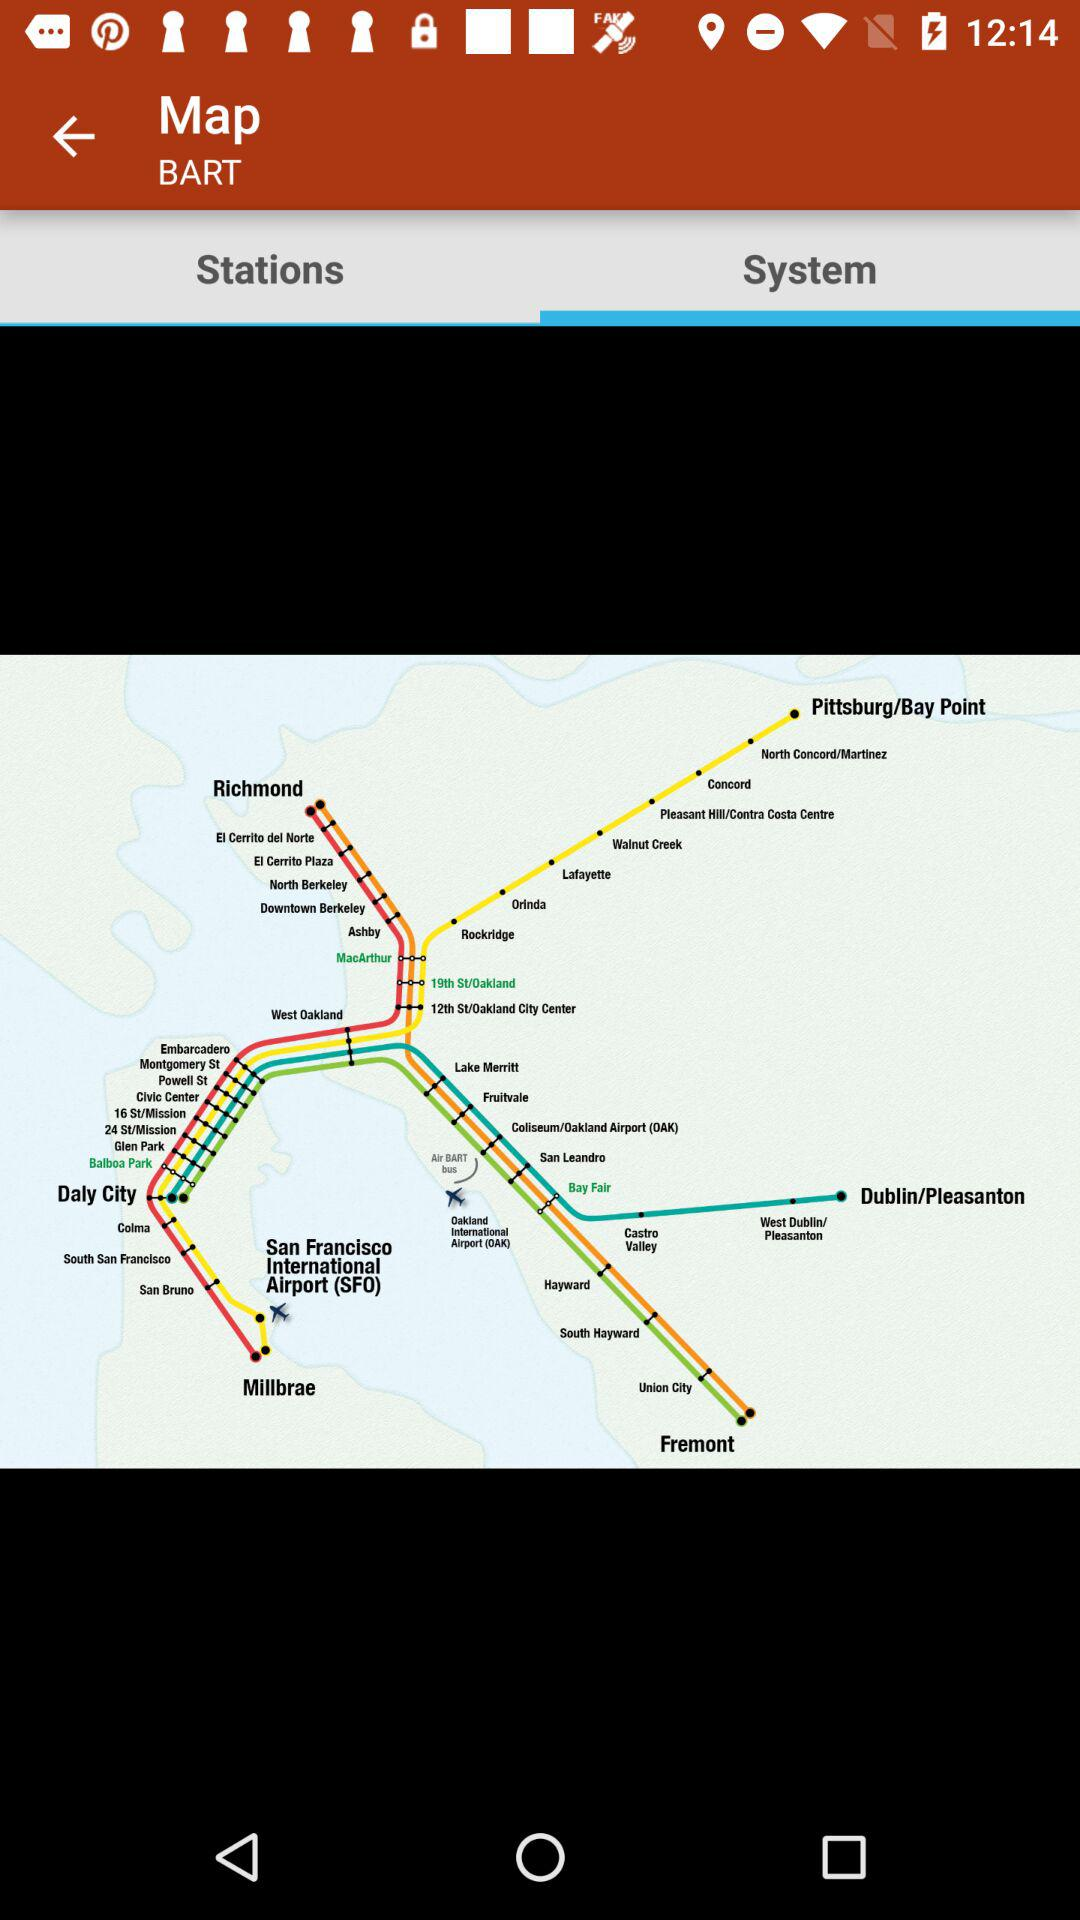Which tab is selected? The selected tab is "System". 